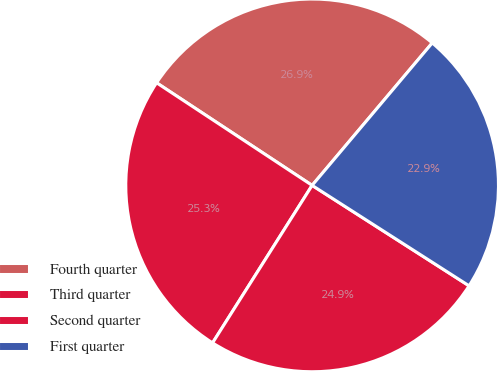Convert chart to OTSL. <chart><loc_0><loc_0><loc_500><loc_500><pie_chart><fcel>Fourth quarter<fcel>Third quarter<fcel>Second quarter<fcel>First quarter<nl><fcel>26.87%<fcel>25.31%<fcel>24.91%<fcel>22.91%<nl></chart> 